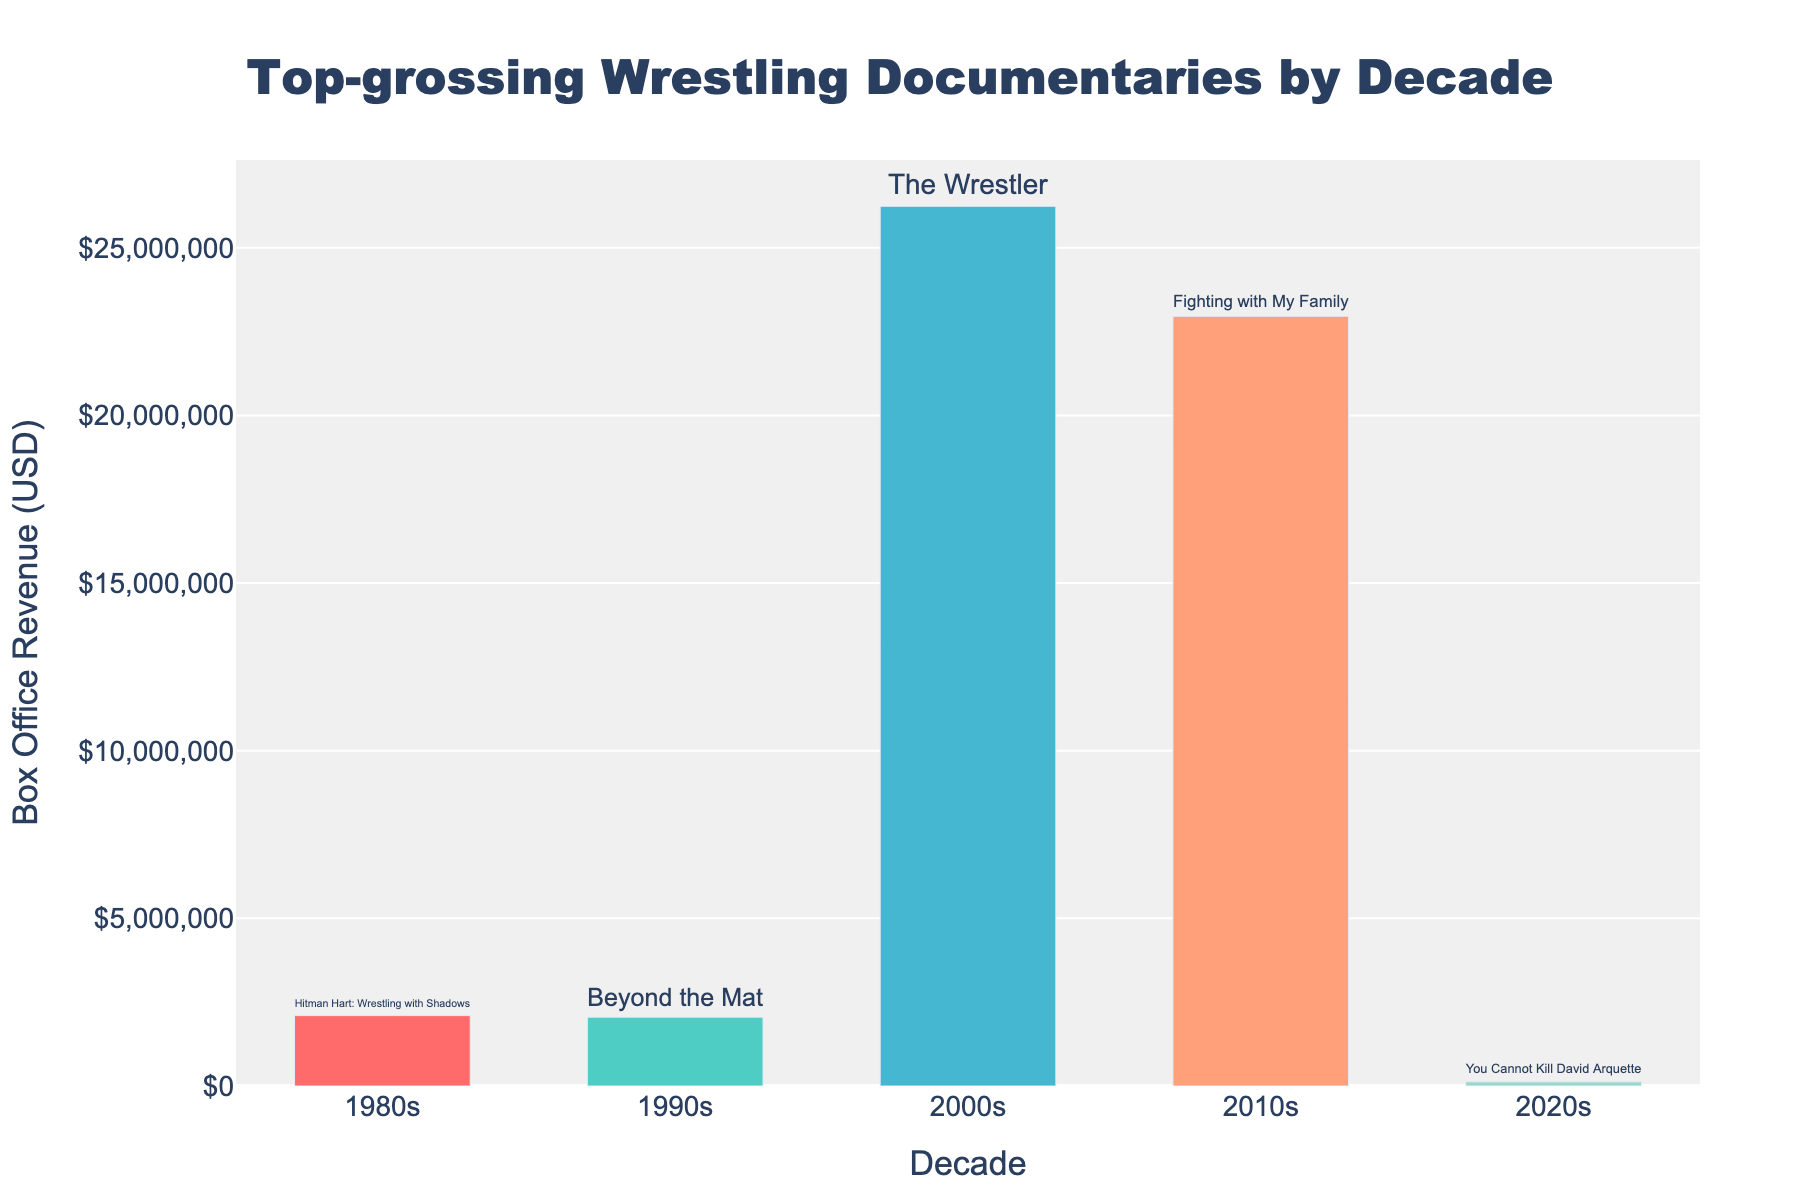Which decade had the highest-grossing wrestling documentary? Look at the heights of the bars. The bar for the 2000s reaches the highest, indicating it had the highest-grossing documentary, "The Wrestler".
Answer: 2000s Which wrestling documentary grossed the lowest among the decades listed? Compare the heights of the bars and check the text labels. "You Cannot Kill David Arquette" in the 2020s has the shortest bar, indicating the lowest gross revenue.
Answer: You Cannot Kill David Arquette How much more did "The Wrestler" gross compared to "Hitman Hart: Wrestling with Shadows"? Subtract the box office revenue of "Hitman Hart: Wrestling with Shadows" from that of "The Wrestler" ($26,238,243 - $2,100,000).
Answer: $24,138,243 What is the combined total box office revenue of the top-grossing wrestling documentaries from the 2000s and 2010s? Add the box office revenues of "The Wrestler" ($26,238,243) and "Fighting with My Family" ($22,958,068).
Answer: $49,196,311 Which documentary had the highest box office revenue in the 2010s, and how much was it? Identify the bar representing the 2010s and read the label and value, which is "Fighting with My Family" with $22,958,068.
Answer: Fighting with My Family, $22,958,068 What is the average box office revenue of the top-grossing wrestling documentaries from all decades listed? Sum the revenues of all documentaries and divide by the number of decades (5). ($2,100,000 + $2,053,203 + $26,238,243 + $22,958,068 + $125,000) / 5.
Answer: $10,294,902 Between the 1980s and 1990s, which documentary had a higher box office revenue and by how much? Compare the revenues of "Hitman Hart: Wrestling with Shadows" ($2,100,000) and "Beyond the Mat" ($2,053,203) by subtracting the smaller from the larger.
Answer: Hitman Hart: Wrestling with Shadows, by $46,797 How do the box office revenues of the 1990s and 2000s compare? Compare the bars for the 1990s and 2000s. The 2000s has a much higher bar with "The Wrestler" grossing $26,238,243 compared to "Beyond the Mat" with $2,053,203 in the 1990s.
Answer: 2000s much higher If you add the box office revenues of the documentaries from the 1980s and 2020s, what would be the total? Add the revenues of "Hitman Hart: Wrestling with Shadows" ($2,100,000) and "You Cannot Kill David Arquette" ($125,000).
Answer: $2,225,000 